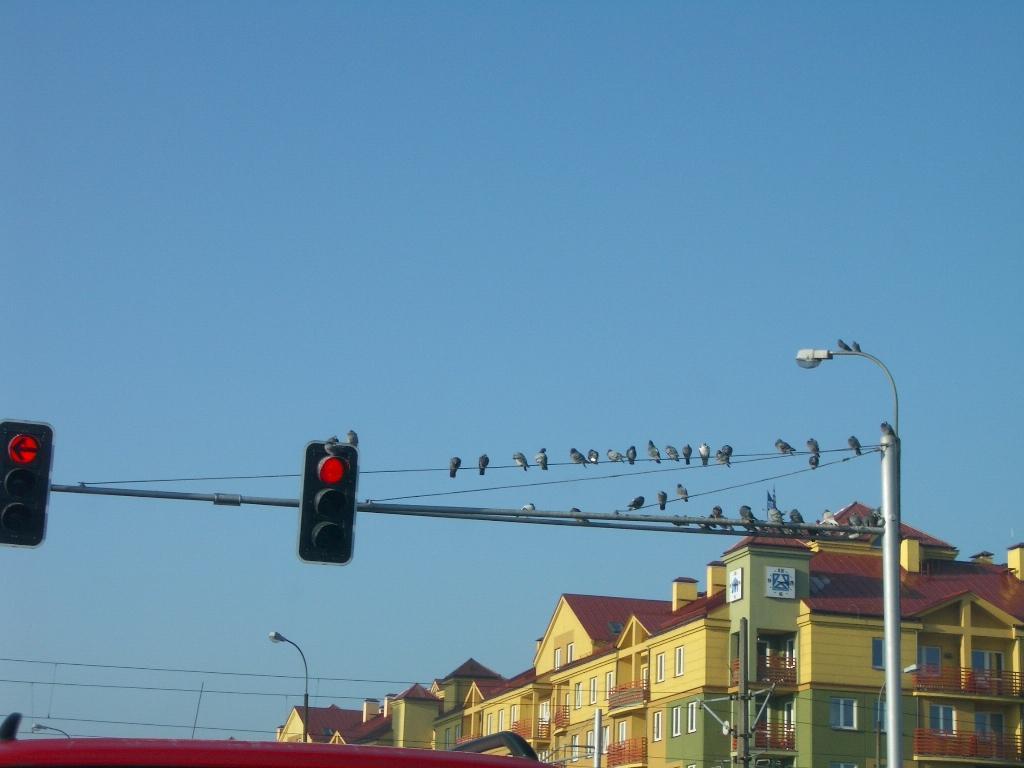Describe this image in one or two sentences. In this picture we can see traffic signals, poles, lights, birds on wires, buildings with windows and some objects and in the background we can see the sky. 